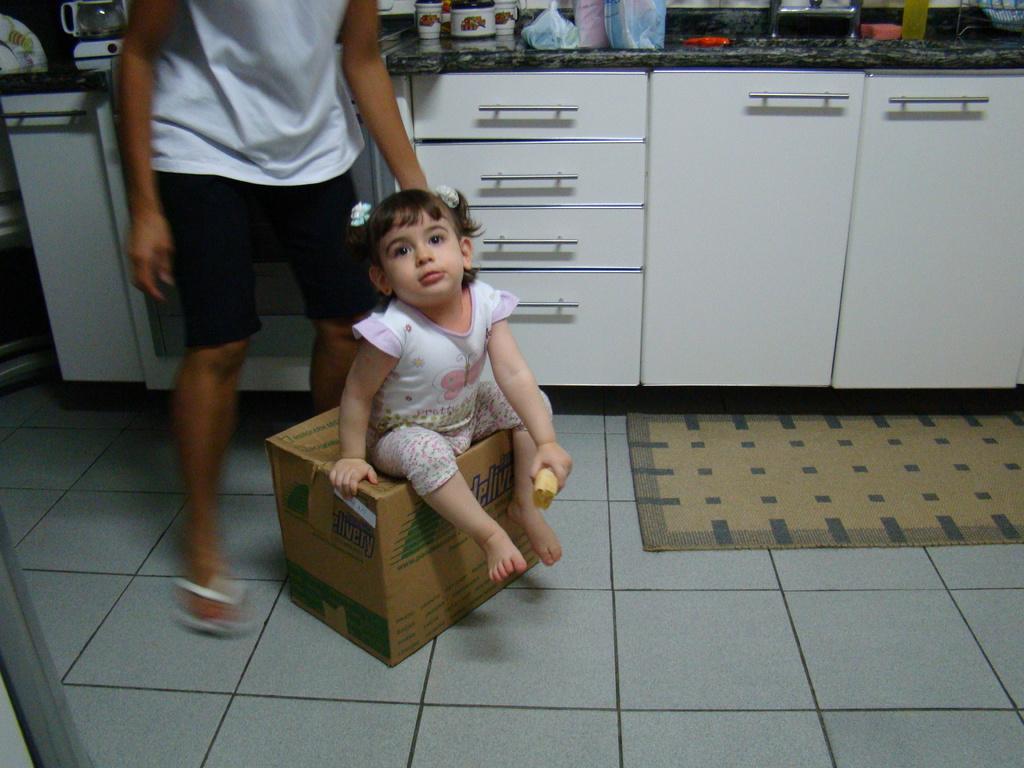What does the blue text on the box say?
Make the answer very short. Delivery. 